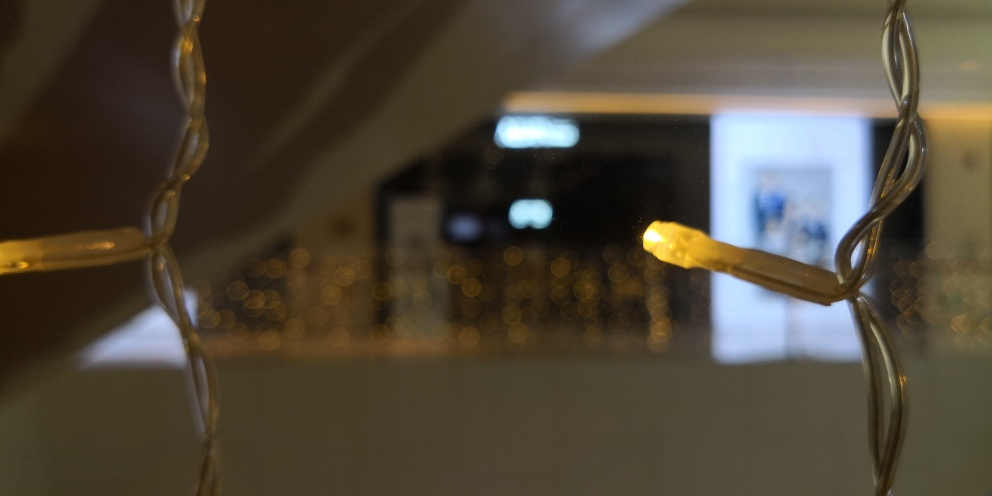How would you describe the grasp of details in this image?
A. fair
B. good
C. poor The grasp of details in this image could be described as 'good' due to the clarity of the focused elements such as the string of lights, which are well-captured with fine detail. However, the background elements are intentionally out of focus to create a bokeh effect that emphasizes the light sources, so detail in that area is limited. 